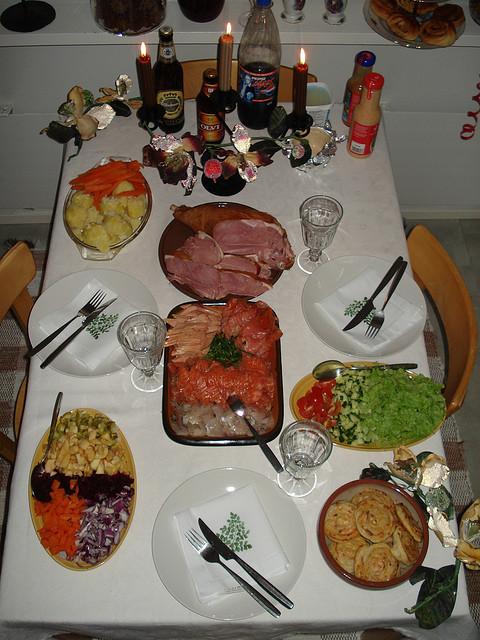How many more serving plates are there compared to dinner plates?
Give a very brief answer. 3. Have people already started eating?
Answer briefly. No. Are there candles?
Short answer required. Yes. What nationalities of cuisine are represented here?
Quick response, please. American. 